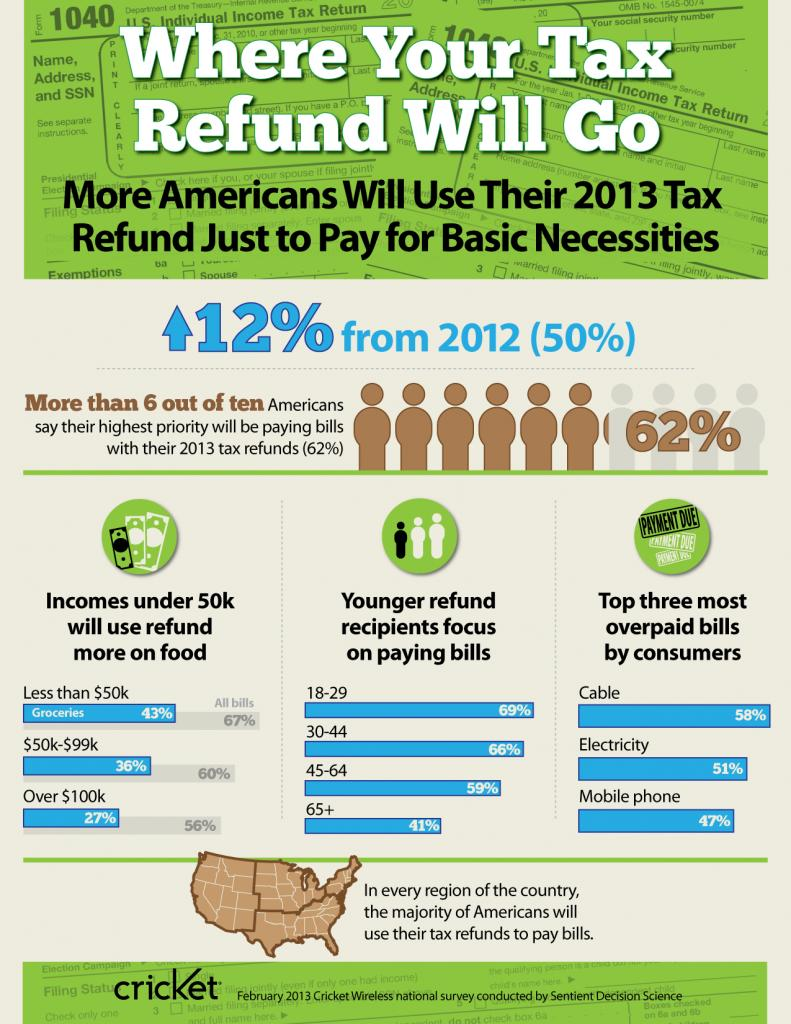Highlight a few significant elements in this photo. Cable, electricity, and mobile phone are the top three most overpaid bills by consumers. A significant percentage of refunds will be used towards food by individuals with an income of over $100,000. According to a recent study, a significant proportion of senior citizens prioritize paying bills over other activities, with 41% stating that this is their primary focus. 